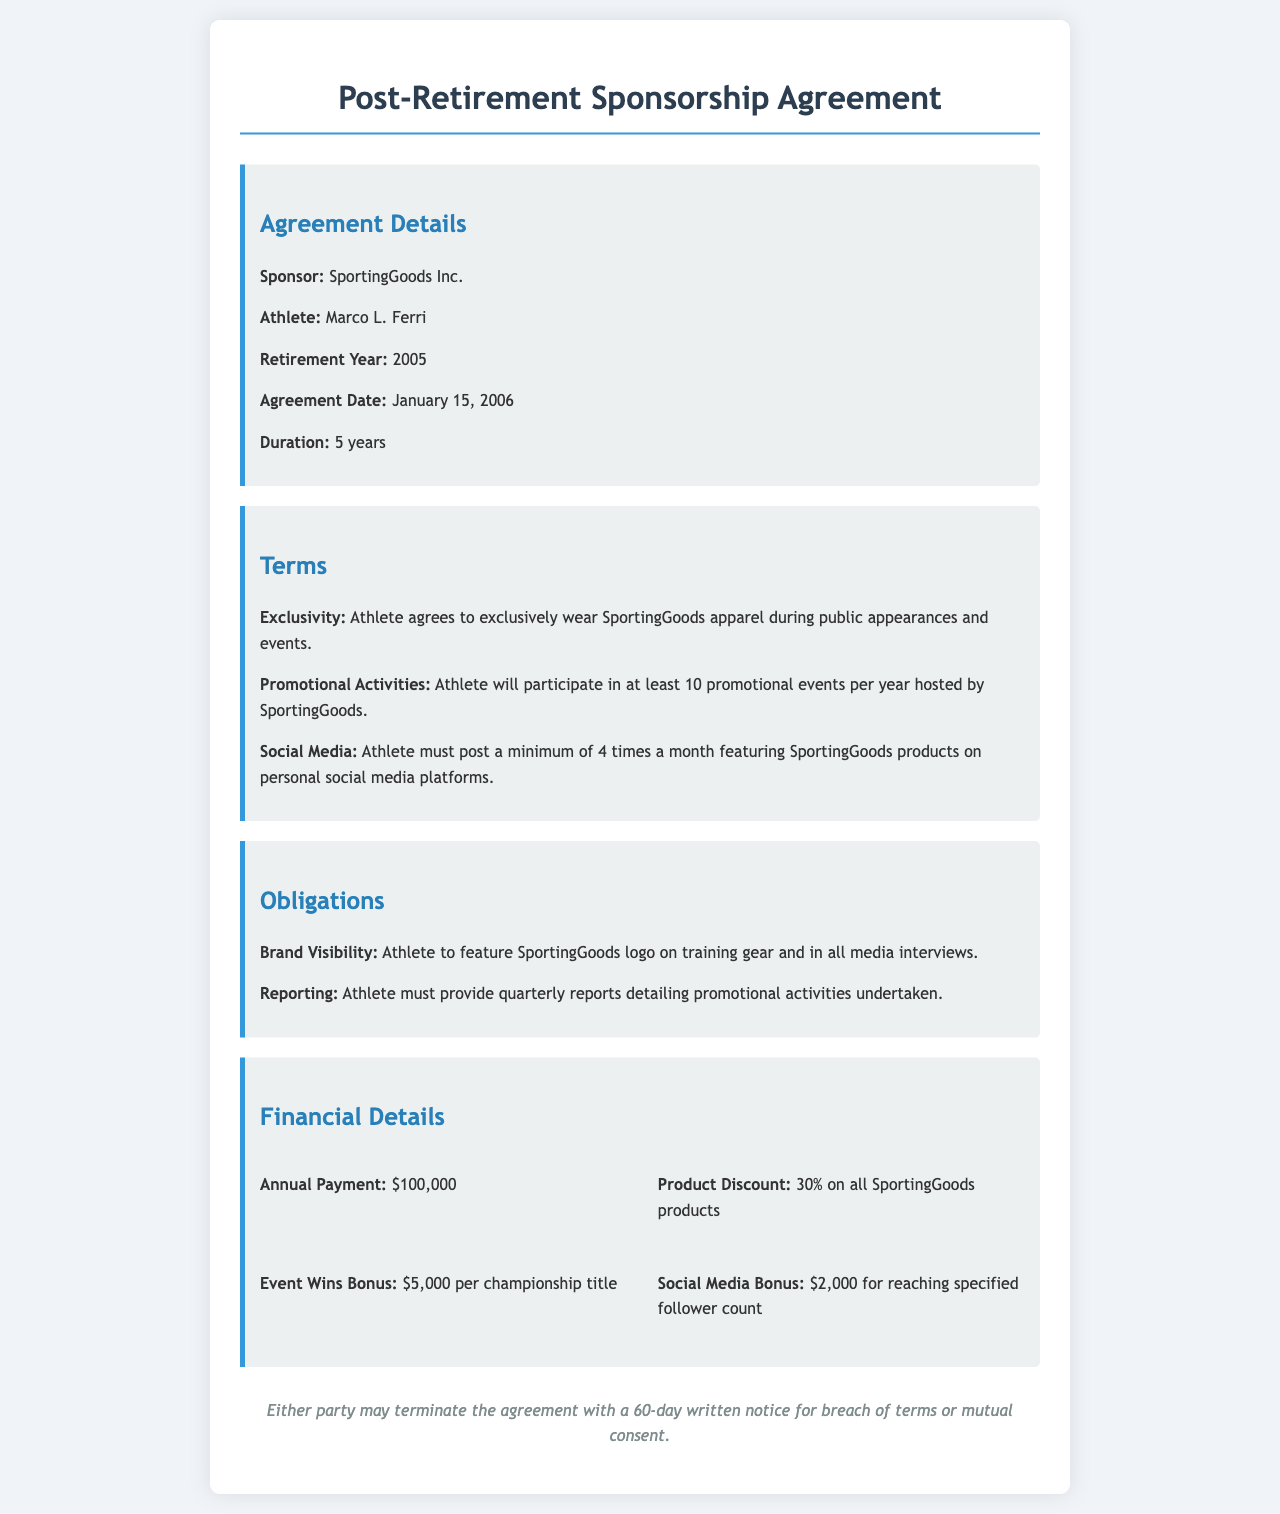What is the name of the sponsor? The sponsor's name is specifically mentioned in the agreement details section of the document.
Answer: SportingGoods Inc What is the duration of the sponsorship agreement? The duration is clearly stated in the agreement details section.
Answer: 5 years What is the annual payment amount stated in the financial details? The annual payment amount can be found in the financial details section.
Answer: $100,000 How many promotional events must the athlete participate in each year? The number of required promotional events is included in the terms section of the document.
Answer: 10 What type of bonus is provided for social media performance? The specific type of bonus related to social media engagement is listed in the financial details section.
Answer: Social Media Bonus What percentage discount does the athlete receive on SportingGoods products? The discount percentage is specified in the financial details section of the document.
Answer: 30% What happens if either party breaches the agreement? The consequence of breaching the agreement is explained in the termination section.
Answer: 60-day written notice Who is the athlete in this agreement? The athlete's name is explicitly mentioned in the agreement details section of the document.
Answer: Marco L. Ferri In what year did the athlete retire? The retirement year is clearly stated in the agreement details section.
Answer: 2005 